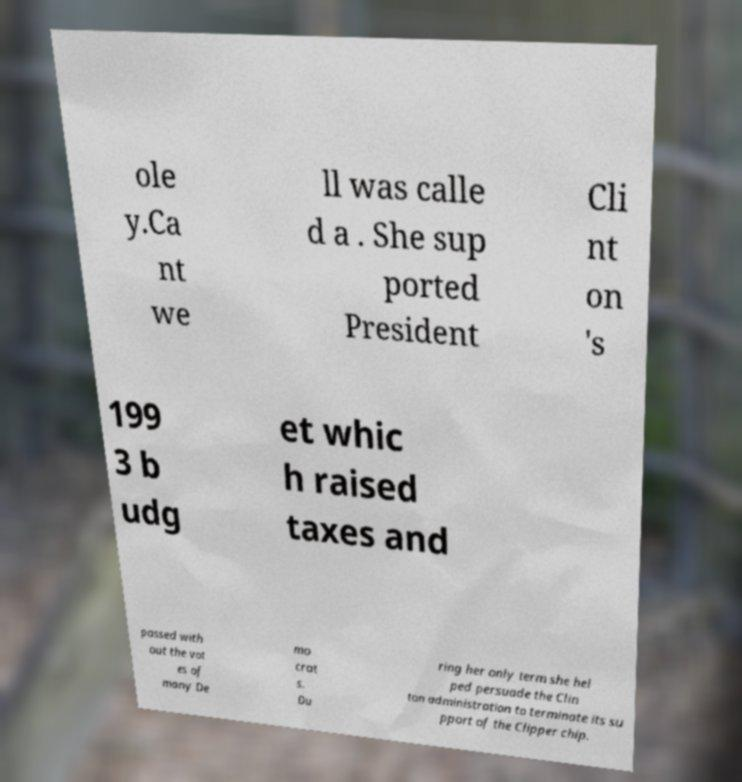Could you assist in decoding the text presented in this image and type it out clearly? ole y.Ca nt we ll was calle d a . She sup ported President Cli nt on 's 199 3 b udg et whic h raised taxes and passed with out the vot es of many De mo crat s. Du ring her only term she hel ped persuade the Clin ton administration to terminate its su pport of the Clipper chip. 